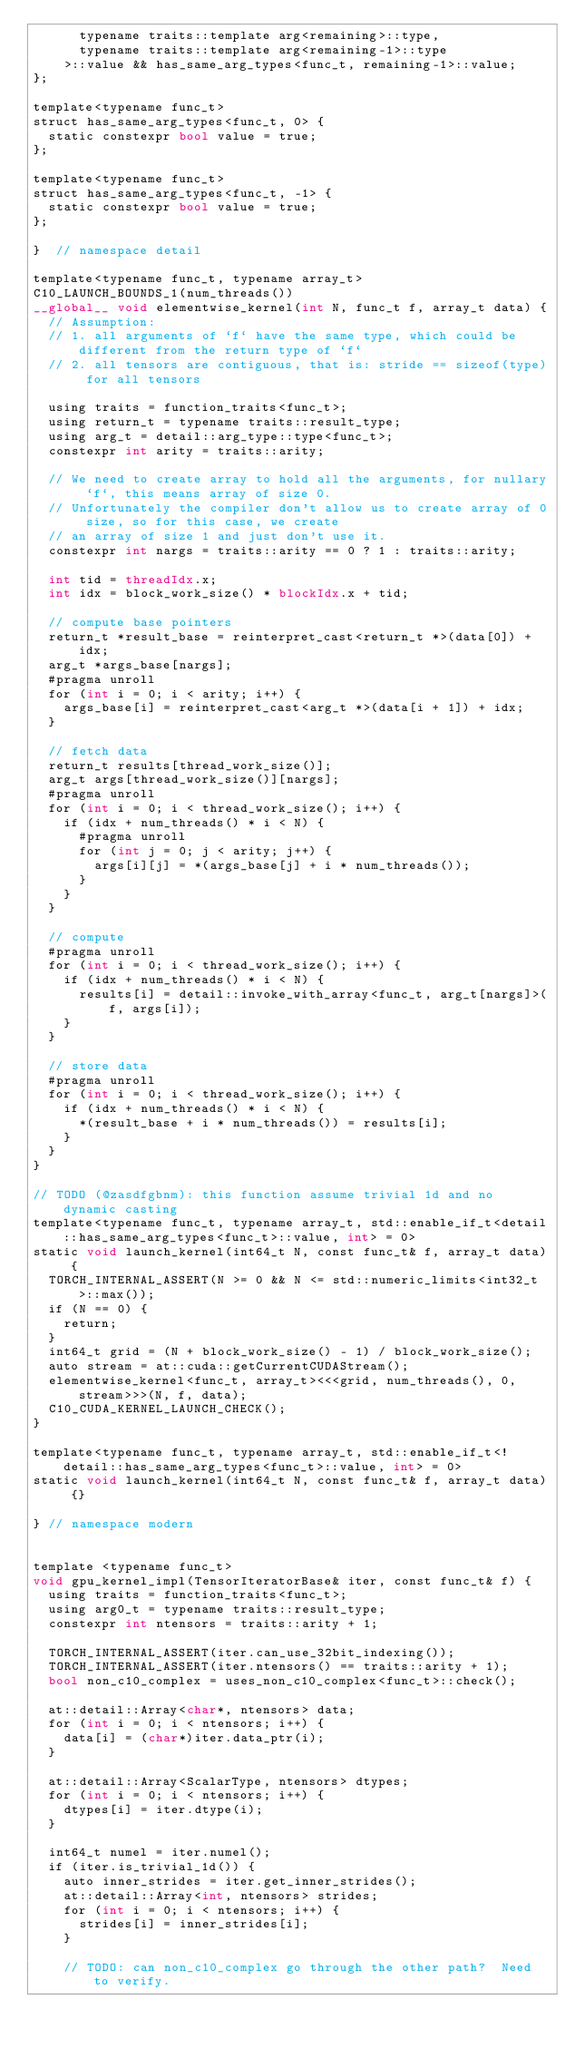<code> <loc_0><loc_0><loc_500><loc_500><_Cuda_>      typename traits::template arg<remaining>::type,
      typename traits::template arg<remaining-1>::type
    >::value && has_same_arg_types<func_t, remaining-1>::value;
};

template<typename func_t>
struct has_same_arg_types<func_t, 0> {
  static constexpr bool value = true;
};

template<typename func_t>
struct has_same_arg_types<func_t, -1> {
  static constexpr bool value = true;
};

}  // namespace detail

template<typename func_t, typename array_t>
C10_LAUNCH_BOUNDS_1(num_threads())
__global__ void elementwise_kernel(int N, func_t f, array_t data) {
  // Assumption:
  // 1. all arguments of `f` have the same type, which could be different from the return type of `f`
  // 2. all tensors are contiguous, that is: stride == sizeof(type) for all tensors

  using traits = function_traits<func_t>;
  using return_t = typename traits::result_type;
  using arg_t = detail::arg_type::type<func_t>;
  constexpr int arity = traits::arity;

  // We need to create array to hold all the arguments, for nullary `f`, this means array of size 0.
  // Unfortunately the compiler don't allow us to create array of 0 size, so for this case, we create
  // an array of size 1 and just don't use it.
  constexpr int nargs = traits::arity == 0 ? 1 : traits::arity;

  int tid = threadIdx.x;
  int idx = block_work_size() * blockIdx.x + tid;

  // compute base pointers
  return_t *result_base = reinterpret_cast<return_t *>(data[0]) + idx;
  arg_t *args_base[nargs];
  #pragma unroll
  for (int i = 0; i < arity; i++) {
    args_base[i] = reinterpret_cast<arg_t *>(data[i + 1]) + idx;
  }

  // fetch data
  return_t results[thread_work_size()];
  arg_t args[thread_work_size()][nargs];
  #pragma unroll
  for (int i = 0; i < thread_work_size(); i++) {
    if (idx + num_threads() * i < N) {
      #pragma unroll
      for (int j = 0; j < arity; j++) {
        args[i][j] = *(args_base[j] + i * num_threads());
      }
    }
  }

  // compute
  #pragma unroll
  for (int i = 0; i < thread_work_size(); i++) {
    if (idx + num_threads() * i < N) {
      results[i] = detail::invoke_with_array<func_t, arg_t[nargs]>(f, args[i]);
    }
  }

  // store data
  #pragma unroll
  for (int i = 0; i < thread_work_size(); i++) {
    if (idx + num_threads() * i < N) {
      *(result_base + i * num_threads()) = results[i];
    }
  }
}

// TODO (@zasdfgbnm): this function assume trivial 1d and no dynamic casting
template<typename func_t, typename array_t, std::enable_if_t<detail::has_same_arg_types<func_t>::value, int> = 0>
static void launch_kernel(int64_t N, const func_t& f, array_t data) {
  TORCH_INTERNAL_ASSERT(N >= 0 && N <= std::numeric_limits<int32_t>::max());
  if (N == 0) {
    return;
  }
  int64_t grid = (N + block_work_size() - 1) / block_work_size();
  auto stream = at::cuda::getCurrentCUDAStream();
  elementwise_kernel<func_t, array_t><<<grid, num_threads(), 0, stream>>>(N, f, data);
  C10_CUDA_KERNEL_LAUNCH_CHECK();
}

template<typename func_t, typename array_t, std::enable_if_t<!detail::has_same_arg_types<func_t>::value, int> = 0>
static void launch_kernel(int64_t N, const func_t& f, array_t data) {}

} // namespace modern


template <typename func_t>
void gpu_kernel_impl(TensorIteratorBase& iter, const func_t& f) {
  using traits = function_traits<func_t>;
  using arg0_t = typename traits::result_type;
  constexpr int ntensors = traits::arity + 1;

  TORCH_INTERNAL_ASSERT(iter.can_use_32bit_indexing());
  TORCH_INTERNAL_ASSERT(iter.ntensors() == traits::arity + 1);
  bool non_c10_complex = uses_non_c10_complex<func_t>::check();

  at::detail::Array<char*, ntensors> data;
  for (int i = 0; i < ntensors; i++) {
    data[i] = (char*)iter.data_ptr(i);
  }

  at::detail::Array<ScalarType, ntensors> dtypes;
  for (int i = 0; i < ntensors; i++) {
    dtypes[i] = iter.dtype(i);
  }

  int64_t numel = iter.numel();
  if (iter.is_trivial_1d()) {
    auto inner_strides = iter.get_inner_strides();
    at::detail::Array<int, ntensors> strides;
    for (int i = 0; i < ntensors; i++) {
      strides[i] = inner_strides[i];
    }

    // TODO: can non_c10_complex go through the other path?  Need to verify.</code> 